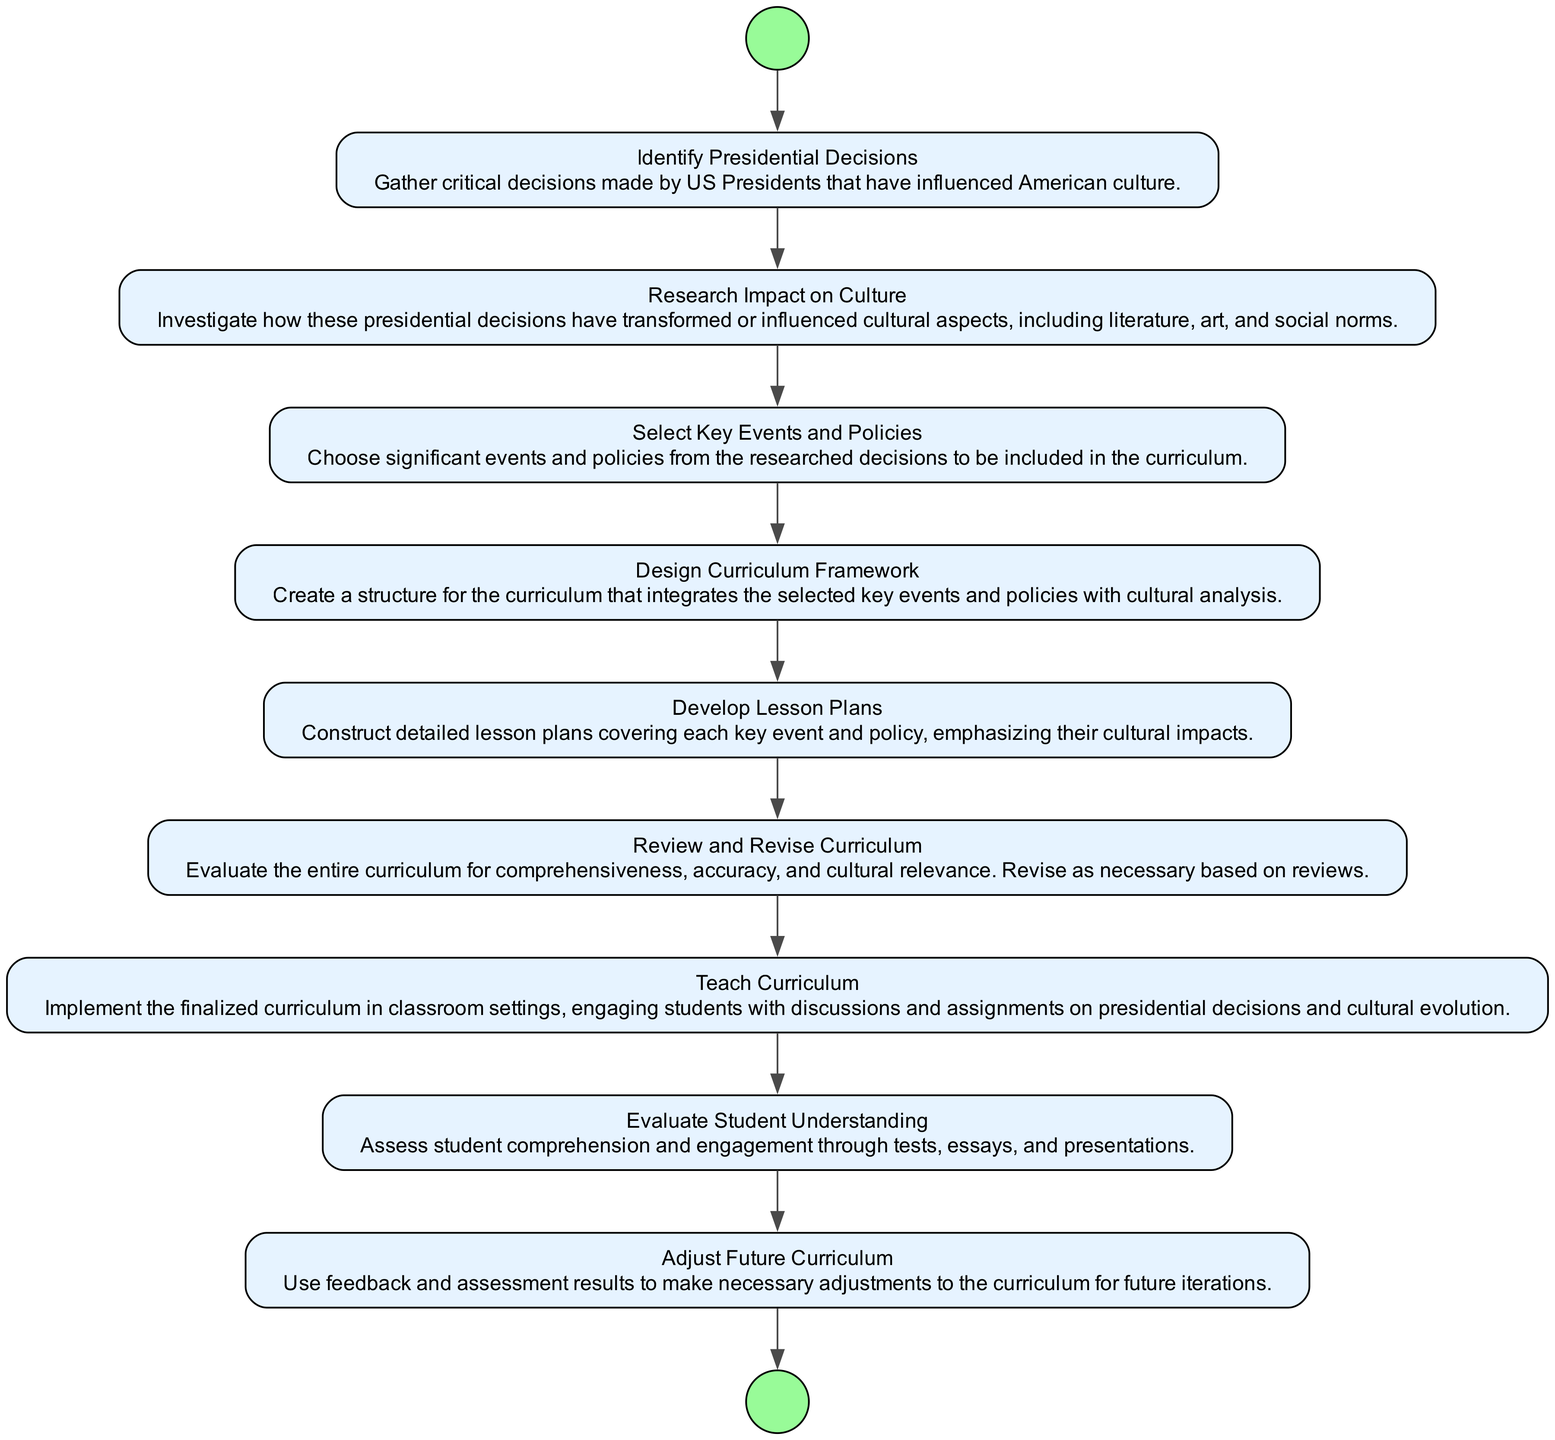What is the first activity in the diagram? The first activity listed in the diagram is "Identify Presidential Decisions" as it is the starting point of the flow.
Answer: Identify Presidential Decisions How many activities are present in the diagram? By counting all the listed activities, there are a total of nine activities in the diagram.
Answer: Nine What is the last activity before teaching the curriculum? The last activity leading up to "Teach Curriculum" is "Review and Revise Curriculum," which is necessary for finalizing the curriculum before implementation.
Answer: Review and Revise Curriculum Which activity involves assessing student comprehension? The activity focused on this task is "Evaluate Student Understanding,” which specifically addresses the assessment of student comprehension and engagement.
Answer: Evaluate Student Understanding What is the next step after developing lesson plans? The activity that follows "Develop Lesson Plans" is "Review and Revise Curriculum," indicating a process of evaluation before teaching.
Answer: Review and Revise Curriculum How many steps lead to the adjustment of future curriculum? There are two steps leading to "Adjust Future Curriculum": "Evaluate Student Understanding" and the feedback from assessment results, creating a feedback loop for curriculum improvement.
Answer: Two What is the relationship between "Select Key Events and Policies" and "Design Curriculum Framework"? The relationship is sequential; "Select Key Events and Policies" is immediately followed by "Design Curriculum Framework," indicating that the selection directly informs the subsequent design of the curriculum.
Answer: Sequential relationship What activity must be completed before engaging in classroom teaching? "Review and Revise Curriculum" must be completed before moving on to "Teach Curriculum," ensuring that the curriculum is polished and ready for classroom use.
Answer: Review and Revise Curriculum What is the key focus of the diagram? The main focus of the diagram is illustrating the process of curating educational curricula that reflects presidential decisions and their cultural impacts.
Answer: Curating educational curricula 